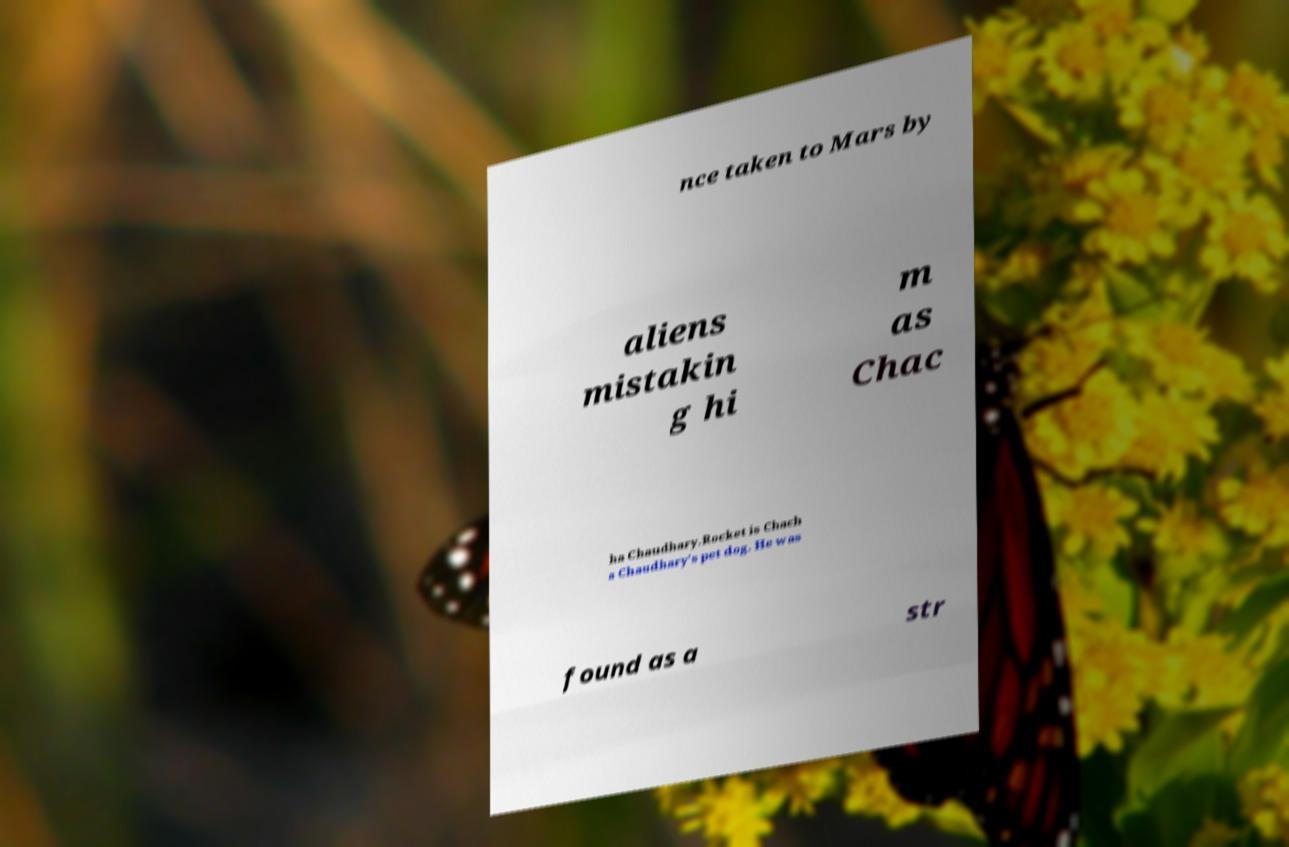What messages or text are displayed in this image? I need them in a readable, typed format. nce taken to Mars by aliens mistakin g hi m as Chac ha Chaudhary.Rocket is Chach a Chaudhary's pet dog. He was found as a str 